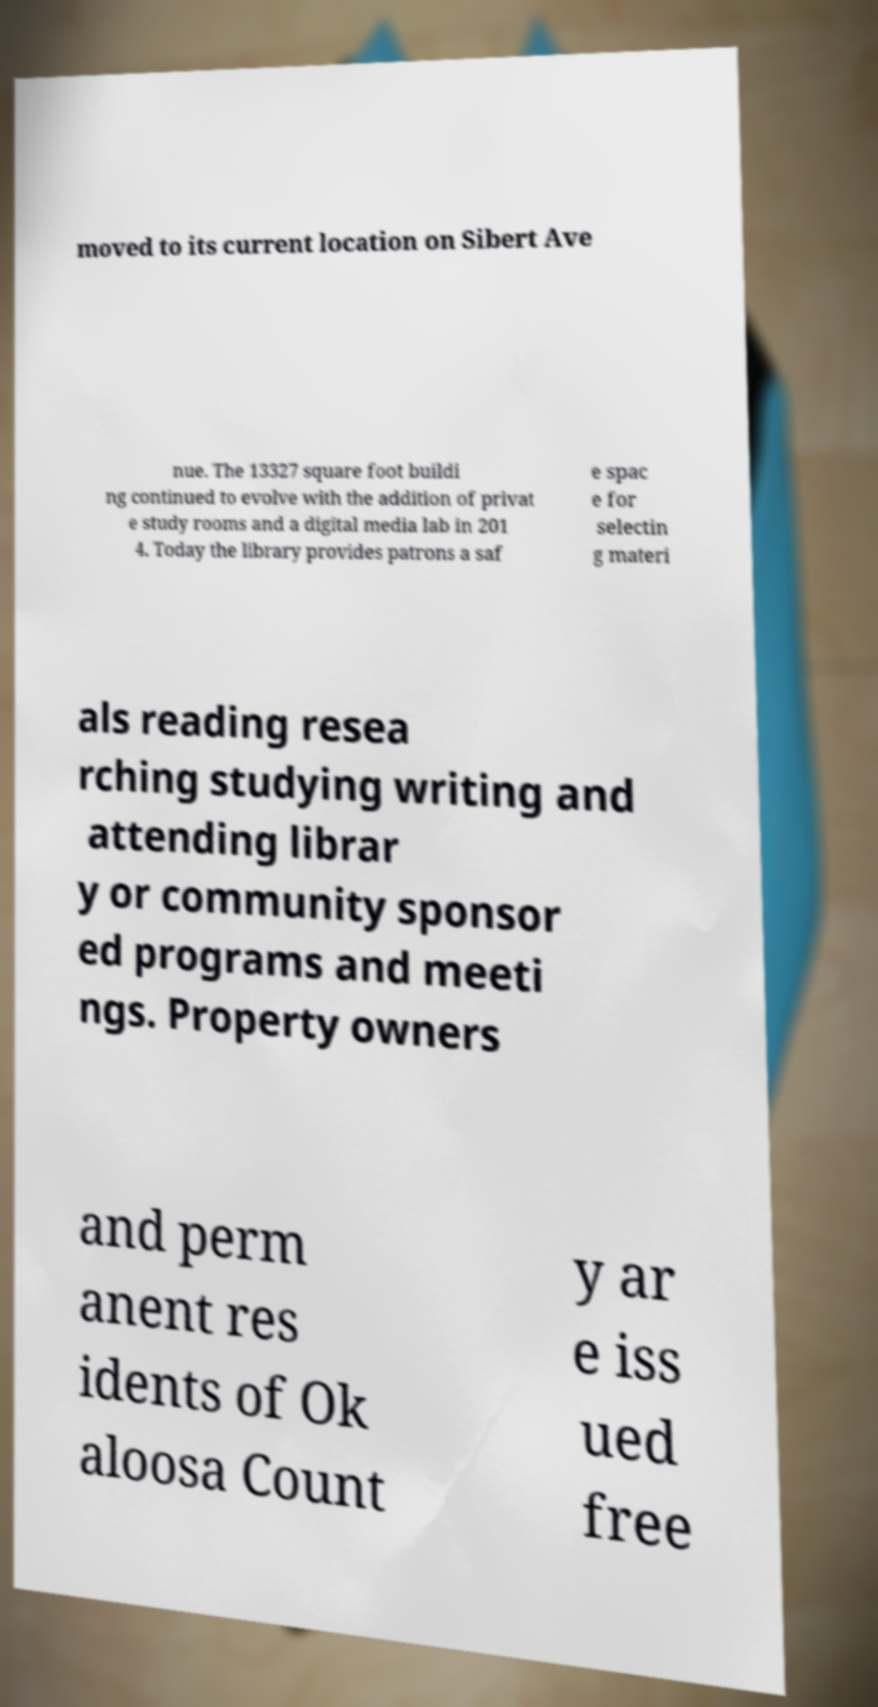I need the written content from this picture converted into text. Can you do that? moved to its current location on Sibert Ave nue. The 13327 square foot buildi ng continued to evolve with the addition of privat e study rooms and a digital media lab in 201 4. Today the library provides patrons a saf e spac e for selectin g materi als reading resea rching studying writing and attending librar y or community sponsor ed programs and meeti ngs. Property owners and perm anent res idents of Ok aloosa Count y ar e iss ued free 